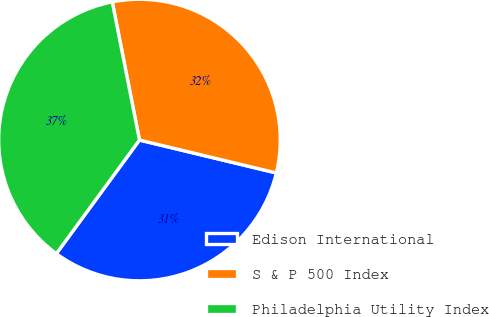<chart> <loc_0><loc_0><loc_500><loc_500><pie_chart><fcel>Edison International<fcel>S & P 500 Index<fcel>Philadelphia Utility Index<nl><fcel>31.3%<fcel>31.85%<fcel>36.85%<nl></chart> 